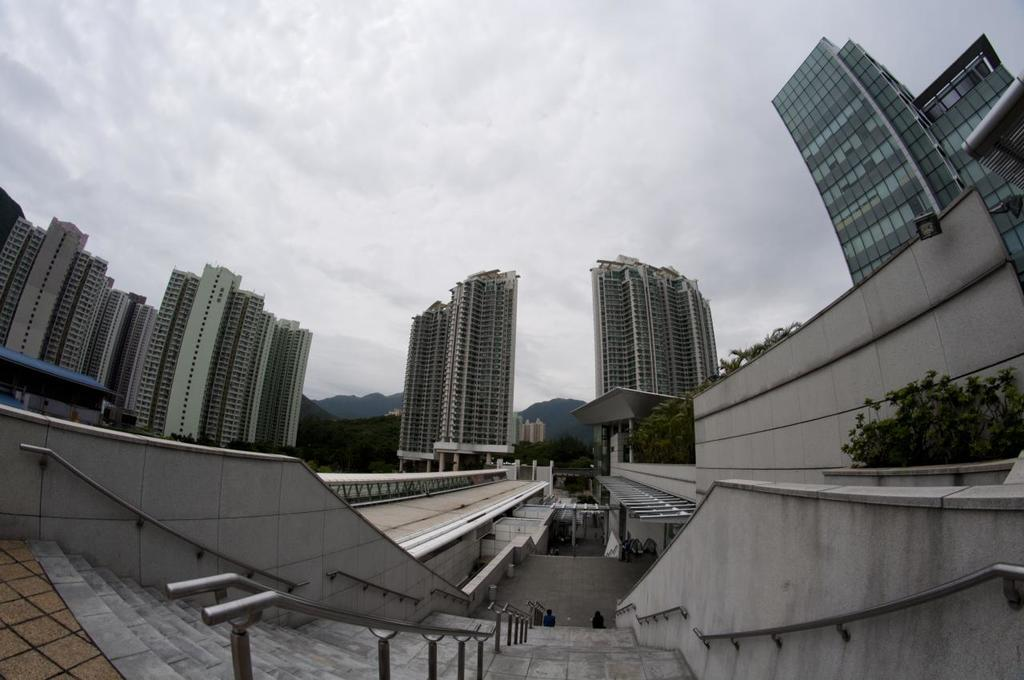What type of structures can be seen in the image? There are buildings in the image. What other elements are present in the image besides buildings? There are plants, at least two persons, trees, and hills in the background of the image. What is the condition of the sky in the image? The sky is cloudy in the background of the image. What type of magic is being performed by the persons in the image? There is no indication of magic or any magical activity in the image. What class of rail is visible in the image? There is no rail present in the image. 